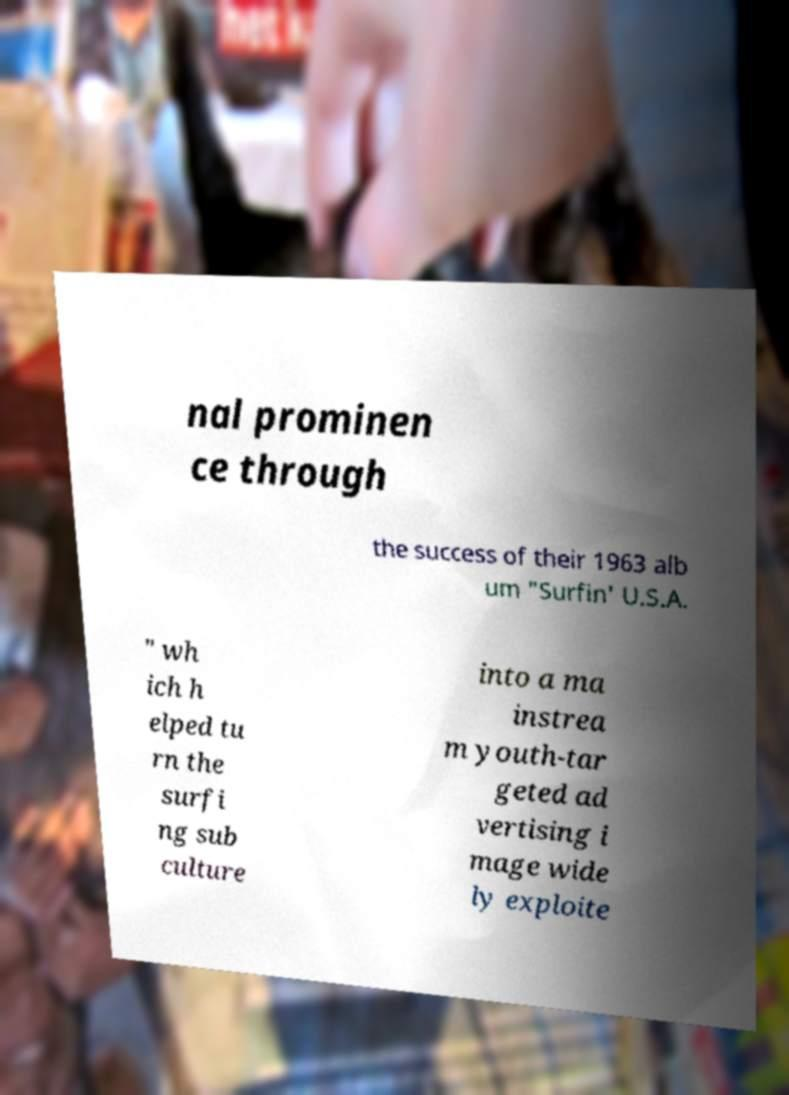Could you extract and type out the text from this image? nal prominen ce through the success of their 1963 alb um "Surfin' U.S.A. " wh ich h elped tu rn the surfi ng sub culture into a ma instrea m youth-tar geted ad vertising i mage wide ly exploite 